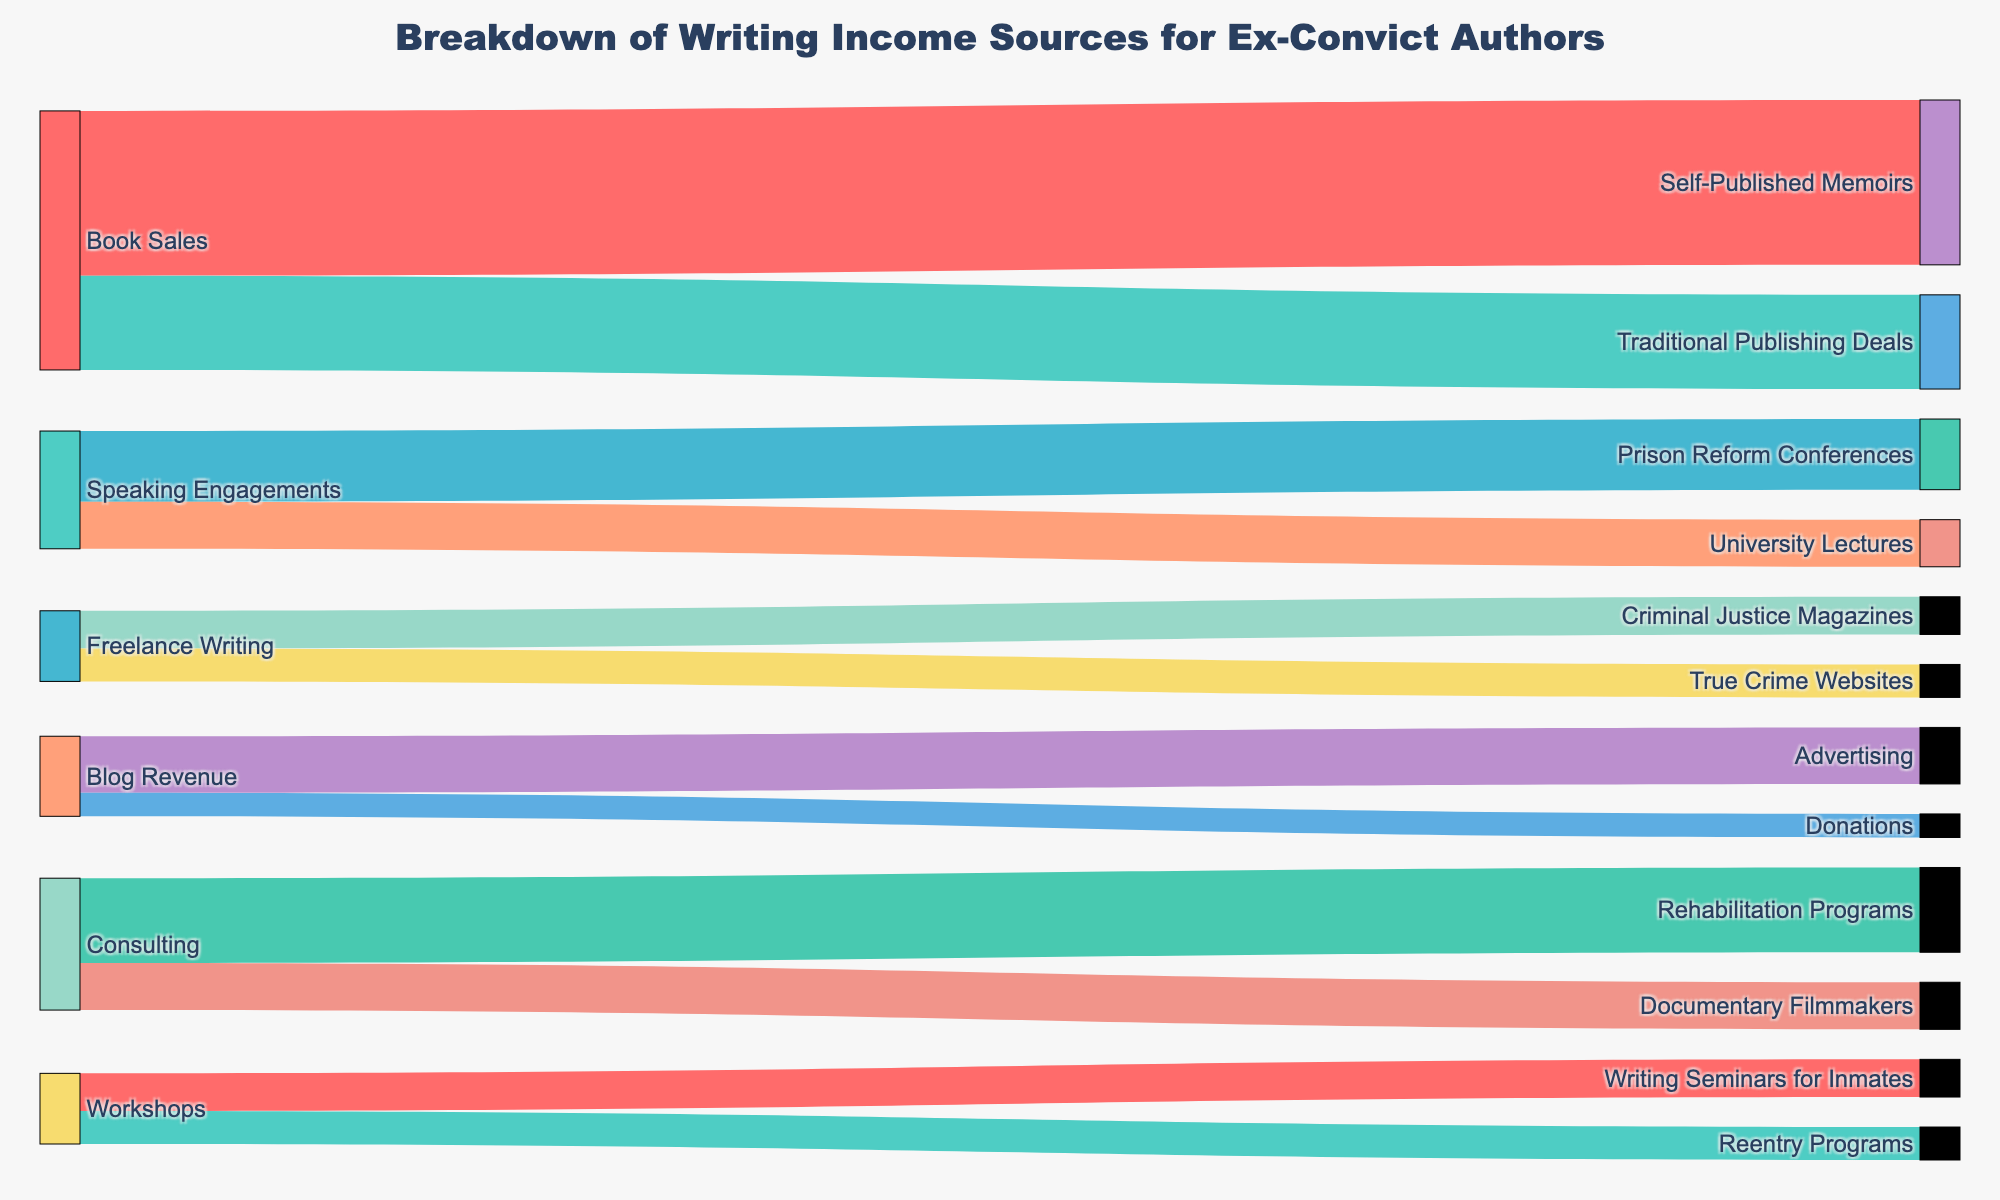what is the total value from "Blog Revenue"? To find the total value, sum the values of the subcategories under "Blog Revenue." These are "Advertising" and "Donations," with values of 12 and 5, respectively. So, 12 + 5 = 17.
Answer: 17 What is the main revenue source for "Book Sales"? By looking at the values connected to "Book Sales," we can compare "Self-Published Memoirs" and "Traditional Publishing Deals." "Self-Published Memoirs" has a value of 35, which is higher than the 20 for "Traditional Publishing Deals."
Answer: Self-Published Memoirs How much more income does "Book Sales" generate from "Self-Published Memoirs" compared to "Traditional Publishing Deals"? Subtract the value from "Traditional Publishing Deals" (20) from the value from "Self-Published Memoirs" (35). So, 35 - 20 = 15.
Answer: 15 Which revenue source has the smallest value? By reviewing all target values, "True Crime Websites" has the smallest value, which is 7.
Answer: True Crime Websites Among "Consulting" income sources, which generates more revenue? Compare the values for "Rehabilitation Programs" and "Documentary Filmmakers." "Rehabilitation Programs" has a value of 18, while "Documentary Filmmakers" has a value of 10.
Answer: Rehabilitation Programs What’s the total value generated by "Freelance Writing"? Sum the values of the subcategories under "Freelance Writing." These are "Criminal Justice Magazines" and "True Crime Websites," with values of 8 and 7, respectively. So, 8 + 7 = 15.
Answer: 15 Which category contributes more income, "Speaking Engagements" or "Workshops"? Compare the total values of the subcategories under "Speaking Engagements" (15 + 10 = 25) and "Workshops" (8 + 7 = 15).
Answer: Speaking Engagements How does the revenue generated by "University Lectures" compare to "Prison Reform Conferences"? Compare the values directly. "University Lectures" generates 10, whereas "Prison Reform Conferences" generates 15. So "University Lectures" generates 5 less.
Answer: 5 less What percentage of "Consulting" income comes from "Documentary Filmmakers"? Calculate the percentage by dividing the value from "Documentary Filmmakers" (10) by the total "Consulting" value (18 + 10 = 28). So, (10 / 28) * 100 ≈ 35.71%.
Answer: ≈ 35.71% Which revenue stream has the highest value? Review all target values and identify the highest. "Self-Published Memoirs" has the highest value of 35.
Answer: Self-Published Memoirs 